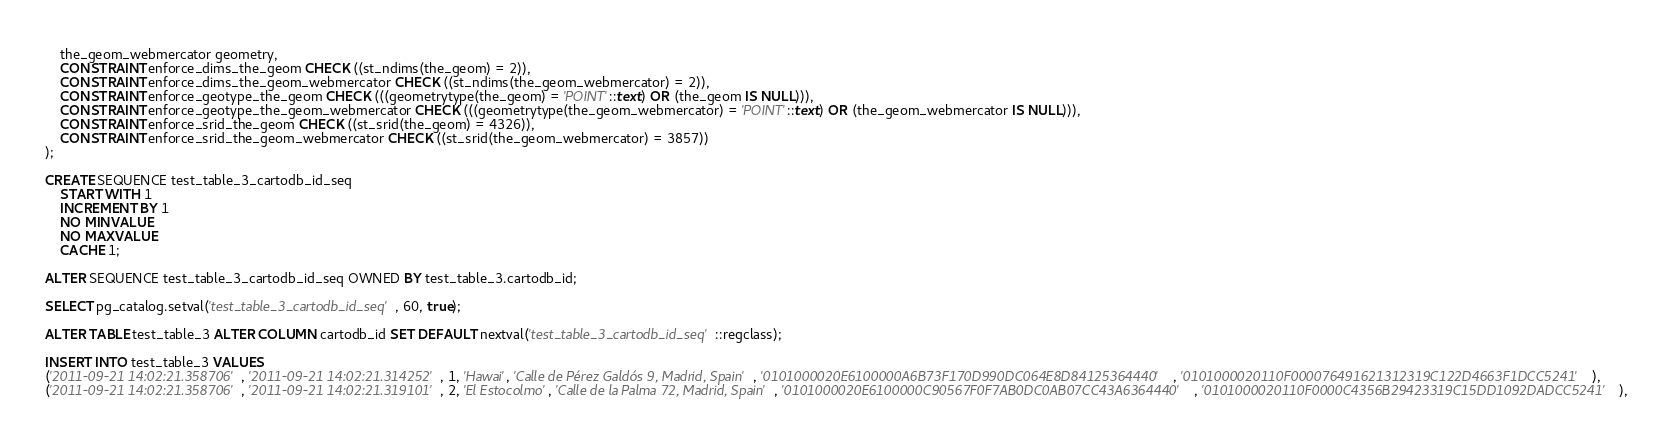<code> <loc_0><loc_0><loc_500><loc_500><_SQL_>    the_geom_webmercator geometry,
    CONSTRAINT enforce_dims_the_geom CHECK ((st_ndims(the_geom) = 2)),
    CONSTRAINT enforce_dims_the_geom_webmercator CHECK ((st_ndims(the_geom_webmercator) = 2)),
    CONSTRAINT enforce_geotype_the_geom CHECK (((geometrytype(the_geom) = 'POINT'::text) OR (the_geom IS NULL))),
    CONSTRAINT enforce_geotype_the_geom_webmercator CHECK (((geometrytype(the_geom_webmercator) = 'POINT'::text) OR (the_geom_webmercator IS NULL))),
    CONSTRAINT enforce_srid_the_geom CHECK ((st_srid(the_geom) = 4326)),
    CONSTRAINT enforce_srid_the_geom_webmercator CHECK ((st_srid(the_geom_webmercator) = 3857))
);

CREATE SEQUENCE test_table_3_cartodb_id_seq
    START WITH 1
    INCREMENT BY 1
    NO MINVALUE
    NO MAXVALUE
    CACHE 1;

ALTER SEQUENCE test_table_3_cartodb_id_seq OWNED BY test_table_3.cartodb_id;

SELECT pg_catalog.setval('test_table_3_cartodb_id_seq', 60, true);

ALTER TABLE test_table_3 ALTER COLUMN cartodb_id SET DEFAULT nextval('test_table_3_cartodb_id_seq'::regclass);

INSERT INTO test_table_3 VALUES
('2011-09-21 14:02:21.358706', '2011-09-21 14:02:21.314252', 1, 'Hawai', 'Calle de Pérez Galdós 9, Madrid, Spain', '0101000020E6100000A6B73F170D990DC064E8D84125364440', '0101000020110F000076491621312319C122D4663F1DCC5241'),
('2011-09-21 14:02:21.358706', '2011-09-21 14:02:21.319101', 2, 'El Estocolmo', 'Calle de la Palma 72, Madrid, Spain', '0101000020E6100000C90567F0F7AB0DC0AB07CC43A6364440', '0101000020110F0000C4356B29423319C15DD1092DADCC5241'),</code> 